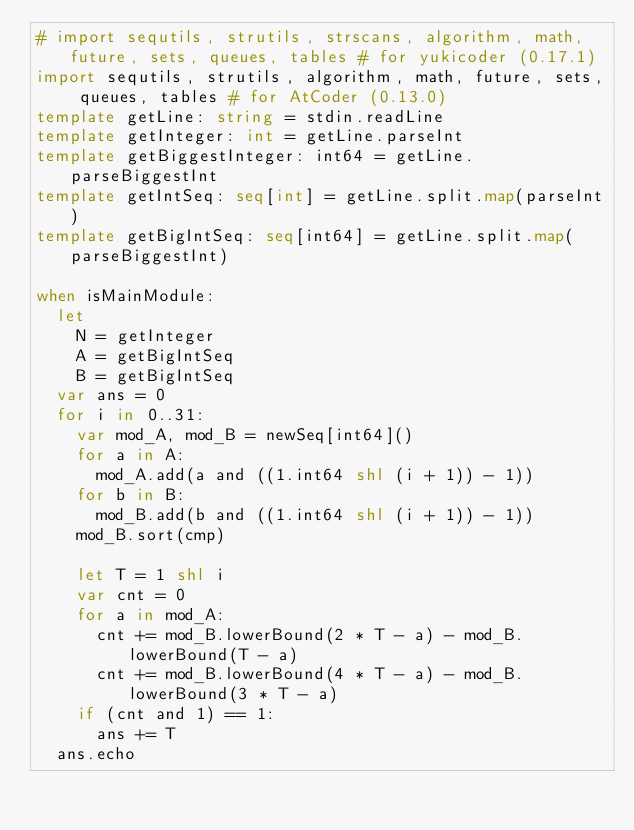<code> <loc_0><loc_0><loc_500><loc_500><_Nim_># import sequtils, strutils, strscans, algorithm, math, future, sets, queues, tables # for yukicoder (0.17.1)
import sequtils, strutils, algorithm, math, future, sets, queues, tables # for AtCoder (0.13.0)
template getLine: string = stdin.readLine
template getInteger: int = getLine.parseInt
template getBiggestInteger: int64 = getLine.parseBiggestInt
template getIntSeq: seq[int] = getLine.split.map(parseInt)
template getBigIntSeq: seq[int64] = getLine.split.map(parseBiggestInt)

when isMainModule:
  let
    N = getInteger
    A = getBigIntSeq
    B = getBigIntSeq
  var ans = 0
  for i in 0..31:
    var mod_A, mod_B = newSeq[int64]()
    for a in A:
      mod_A.add(a and ((1.int64 shl (i + 1)) - 1))
    for b in B:
      mod_B.add(b and ((1.int64 shl (i + 1)) - 1))
    mod_B.sort(cmp)

    let T = 1 shl i
    var cnt = 0
    for a in mod_A:
      cnt += mod_B.lowerBound(2 * T - a) - mod_B.lowerBound(T - a)
      cnt += mod_B.lowerBound(4 * T - a) - mod_B.lowerBound(3 * T - a)
    if (cnt and 1) == 1:
      ans += T
  ans.echo
</code> 